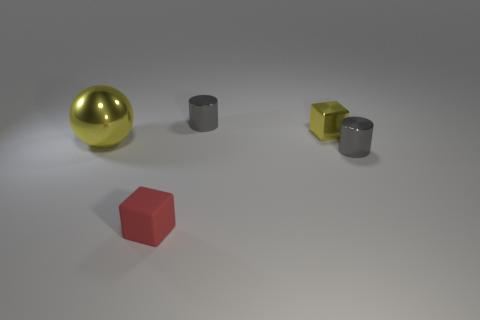What number of big shiny objects have the same shape as the small red rubber object?
Your answer should be very brief. 0. Is the material of the small red block the same as the tiny yellow block?
Offer a terse response. No. What is the shape of the gray metallic object that is behind the yellow thing that is on the right side of the small matte object?
Offer a very short reply. Cylinder. What number of metallic spheres are on the left side of the yellow metal object to the right of the red matte thing?
Ensure brevity in your answer.  1. There is a object that is left of the metallic cube and in front of the large metallic sphere; what is it made of?
Your response must be concise. Rubber. What is the shape of the yellow object that is the same size as the red rubber cube?
Provide a short and direct response. Cube. What color is the tiny shiny cylinder that is on the left side of the cylinder in front of the gray metallic object behind the large metallic sphere?
Your response must be concise. Gray. What number of things are either tiny metal things that are behind the small yellow block or large blue metal things?
Offer a very short reply. 1. What material is the yellow block that is the same size as the red thing?
Keep it short and to the point. Metal. What is the material of the block that is right of the gray metal cylinder behind the small cylinder in front of the yellow sphere?
Keep it short and to the point. Metal. 